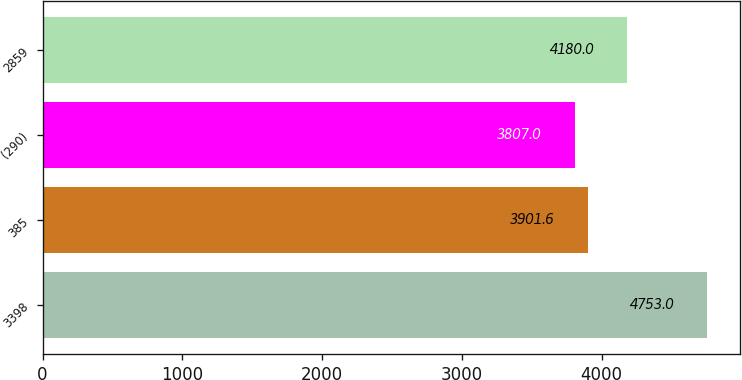<chart> <loc_0><loc_0><loc_500><loc_500><bar_chart><fcel>3398<fcel>385<fcel>(290)<fcel>2859<nl><fcel>4753<fcel>3901.6<fcel>3807<fcel>4180<nl></chart> 